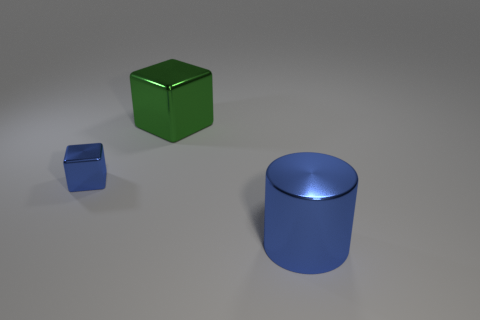Add 2 big green metallic objects. How many objects exist? 5 Subtract all cubes. How many objects are left? 1 Subtract all blue metallic cubes. Subtract all matte spheres. How many objects are left? 2 Add 2 big blue metallic cylinders. How many big blue metallic cylinders are left? 3 Add 2 big metallic balls. How many big metallic balls exist? 2 Subtract 0 yellow cylinders. How many objects are left? 3 